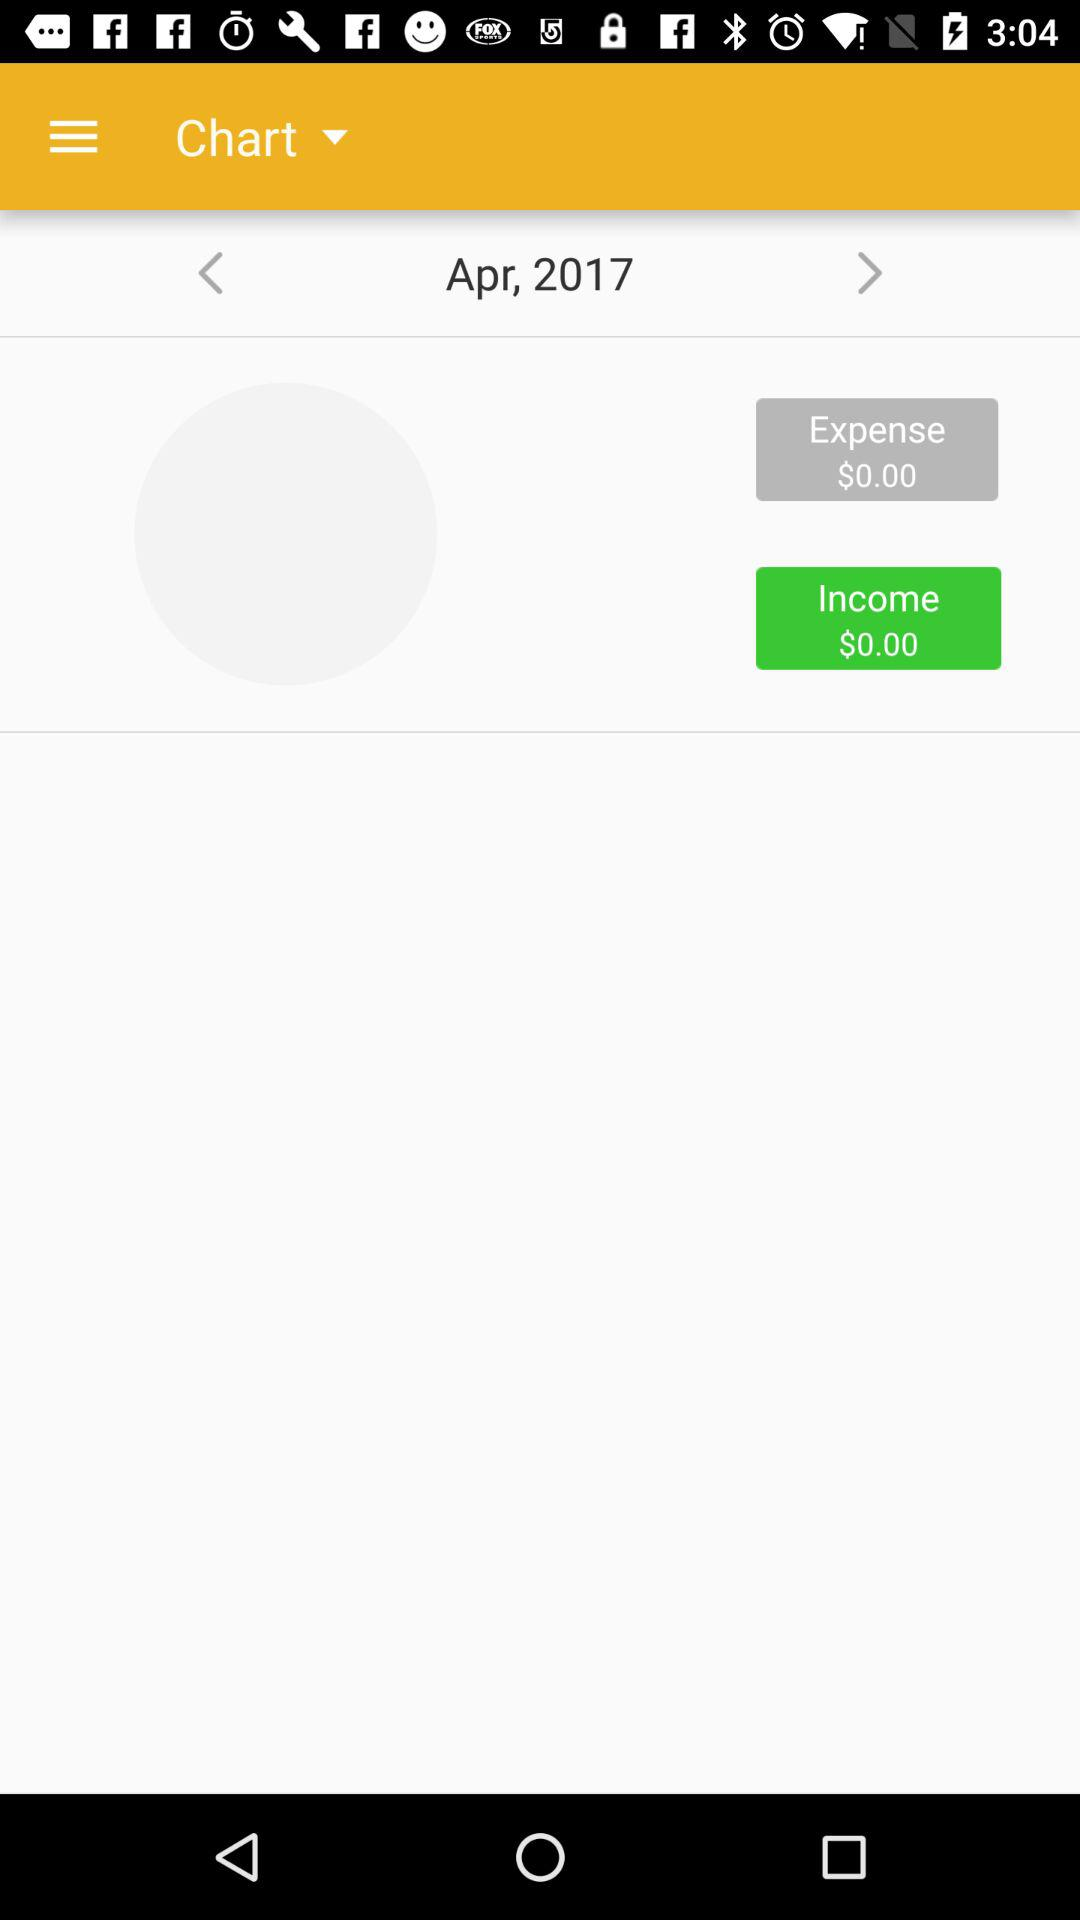What are the expenses? The expenses are $0. 